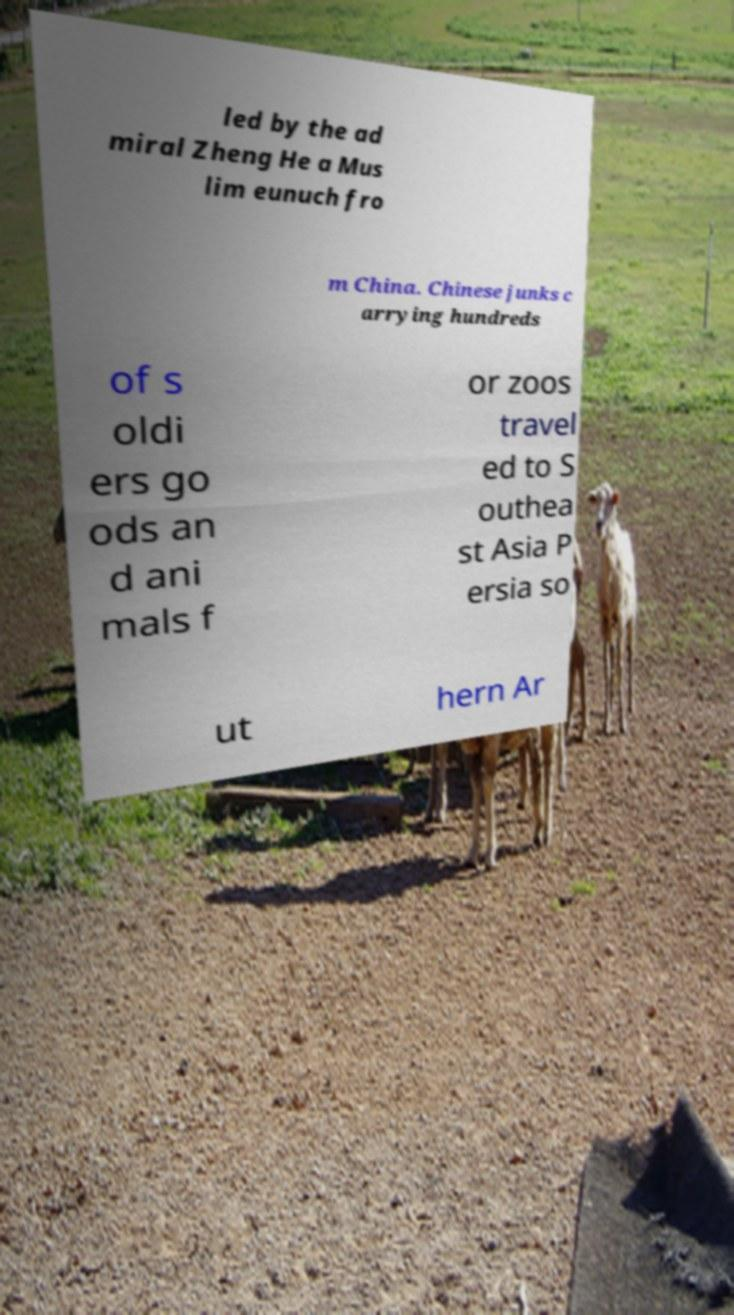I need the written content from this picture converted into text. Can you do that? led by the ad miral Zheng He a Mus lim eunuch fro m China. Chinese junks c arrying hundreds of s oldi ers go ods an d ani mals f or zoos travel ed to S outhea st Asia P ersia so ut hern Ar 